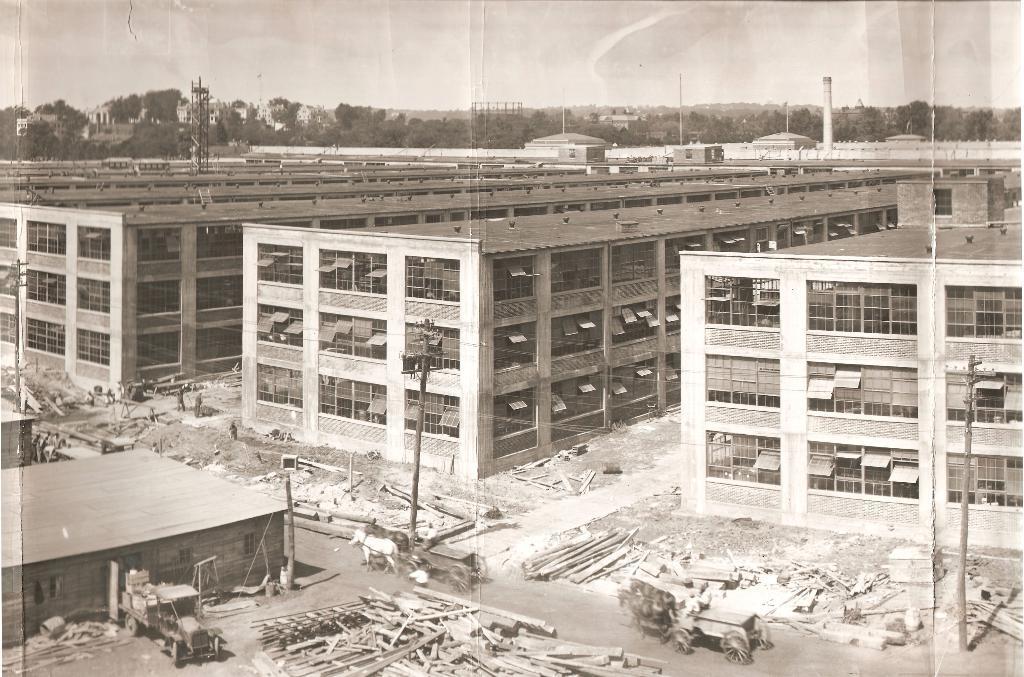In one or two sentences, can you explain what this image depicts? In this image I can see many buildings. In-front of the buildings I can see the road and there are the carts on the road. I can also see two animals. In the background there are many trees, poles and the sky. And this is a black and white image. 